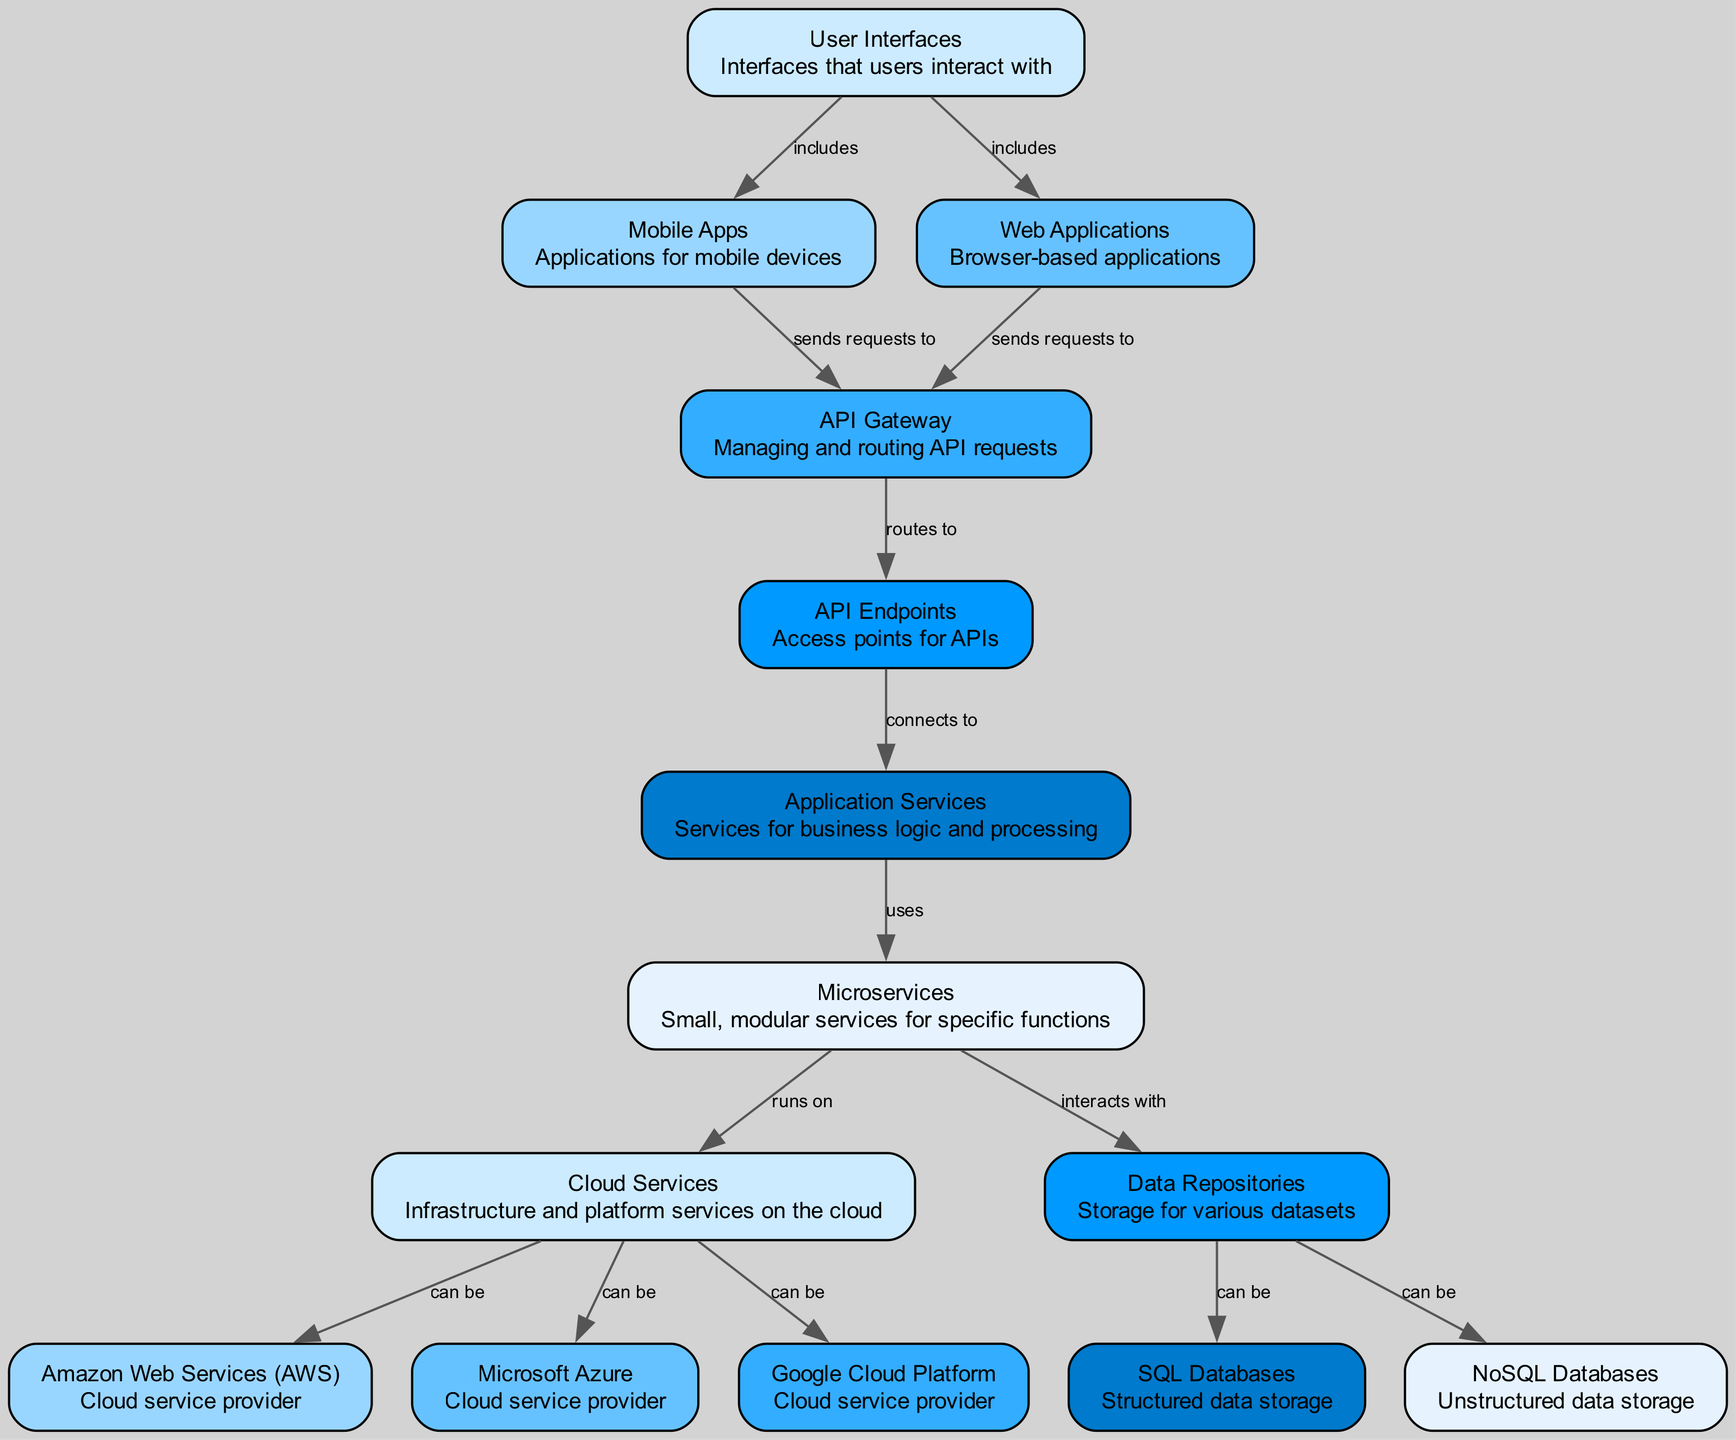What are the components that users interact with? The diagram identifies "User Interfaces" as the primary component that users interact with.
Answer: User Interfaces How many cloud service providers are represented in the diagram? The diagram includes three distinct nodes labeled as "Amazon Web Services (AWS)", "Microsoft Azure", and "Google Cloud Platform".
Answer: Three What does the API Gateway do? The API Gateway manages and routes API requests, as indicated by the description of the node in the diagram.
Answer: Managing and routing API requests Which component sends requests to the API Gateway? Both "Mobile Apps" and "Web Applications" are shown in the diagram to send requests to the API Gateway.
Answer: Mobile Apps and Web Applications How do microservices interact with data repositories? Microservices interact with data repositories, as indicated in the diagram by the directed edge from "Microservices" to "Data Repositories".
Answer: Interacts with Which cloud service is commonly used for application services? The diagram suggests that microservices "run on" cloud services, indicating a reliance on such infrastructures as AWS, Azure, or Google Cloud Platform for application services.
Answer: Cloud Services What types of databases can the data repositories have? The diagram specifies that data repositories can consist of "SQL Databases" for structured data and "NoSQL Databases" for unstructured data, indicating two types of databases.
Answer: SQL Databases and NoSQL Databases What is the relationship between web applications and API gateway? Web applications send requests to the API Gateway, as demonstrated by the edge connecting these two components in the diagram.
Answer: Sends requests to What types of user interfaces are included under "User Interfaces"? The diagram specifies "Mobile Apps" and "Web Applications" as the components included under "User Interfaces".
Answer: Mobile Apps and Web Applications 